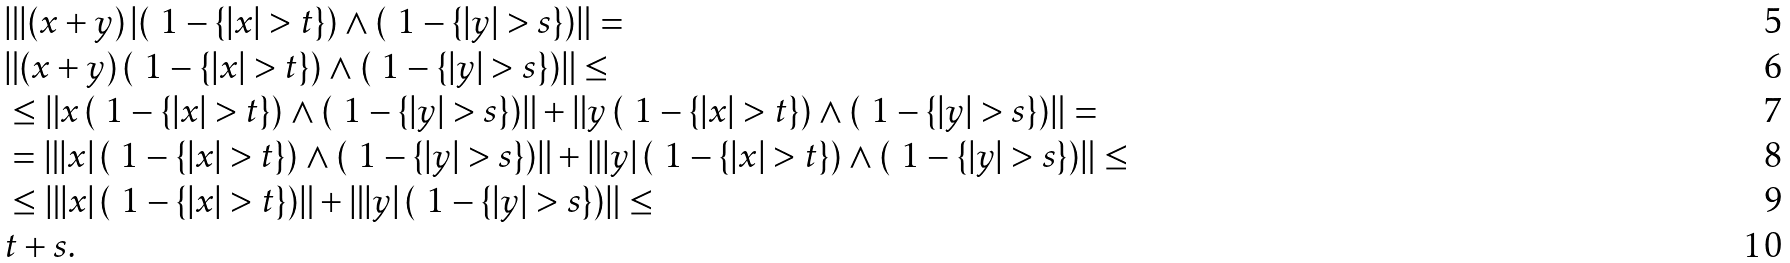<formula> <loc_0><loc_0><loc_500><loc_500>& \| | ( x + y ) \, | ( \ 1 - \{ | x | > t \} ) \wedge ( \ 1 - \{ | y | > s \} ) \| = \\ & \| ( x + y ) \, ( \ 1 - \{ | x | > t \} ) \wedge ( \ 1 - \{ | y | > s \} ) \| \leq \\ & \leq \| x \, ( \ 1 - \{ | x | > t \} ) \wedge ( \ 1 - \{ | y | > s \} ) \| + \| y \, ( \ 1 - \{ | x | > t \} ) \wedge ( \ 1 - \{ | y | > s \} ) \| = \\ & = \| | x | \, ( \ 1 - \{ | x | > t \} ) \wedge ( \ 1 - \{ | y | > s \} ) \| + \| | y | \, ( \ 1 - \{ | x | > t \} ) \wedge ( \ 1 - \{ | y | > s \} ) \| \leq \\ & \leq \| | x | \, ( \ 1 - \{ | x | > t \} ) \| + \| | y | \, ( \ 1 - \{ | y | > s \} ) \| \leq \\ & t + s .</formula> 